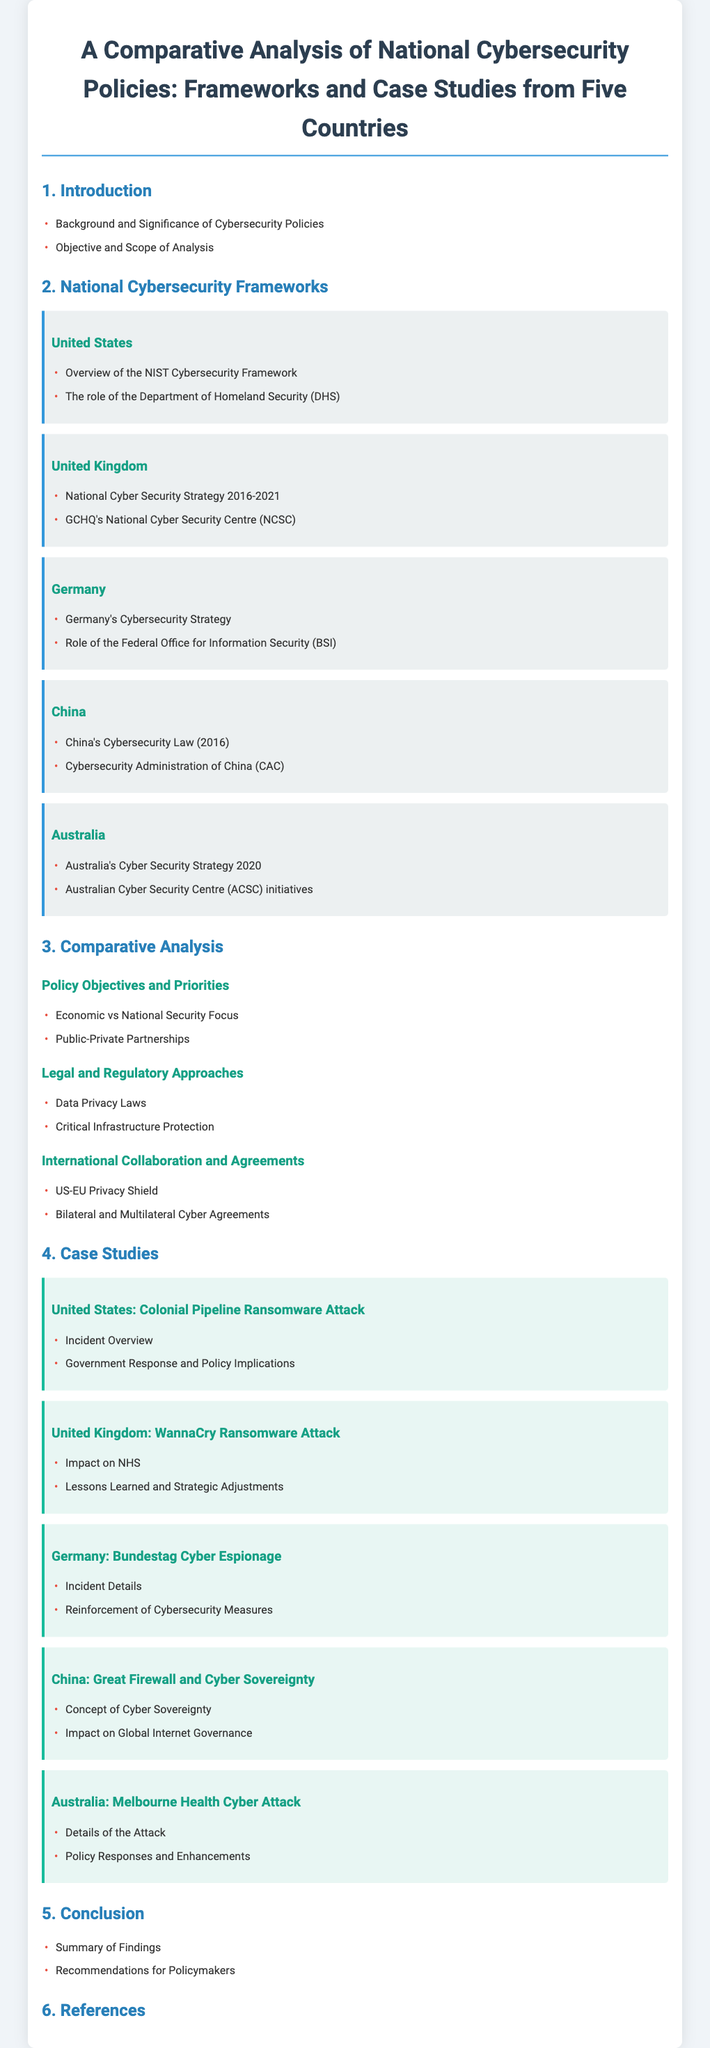What is the title of the document? The title is found at the top of the document, which summarizes the focus on national cybersecurity policies across different countries.
Answer: A Comparative Analysis of National Cybersecurity Policies: Frameworks and Case Studies from Five Countries Which country has the National Cyber Security Strategy 2016-2021? This information can be found in the overview of national cybersecurity frameworks under the United Kingdom section.
Answer: United Kingdom What year was China's Cybersecurity Law enacted? The year is stated in the section discussing China's cybersecurity framework and laws.
Answer: 2016 What is the primary focus of the United States' NIST Cybersecurity Framework? This information is included under the overview of the framework provided for the United States.
Answer: Cybersecurity Which attack impacted the UK's National Health Service? This is a specific case study covered in the document discussing significant cybersecurity incidents.
Answer: WannaCry Ransomware Attack What does Germany's Federal Office for Information Security (BSI) primarily handle? This detail is mentioned in the description of Germany's cybersecurity framework.
Answer: Cybersecurity What type of partnerships are emphasized in the comparative analysis of policy objectives? This part of the document addresses collaborative efforts in the context of national cybersecurity policies.
Answer: Public-Private Partnerships How many countries' cybersecurity frameworks are analyzed? The overall structure of the document indicates the number of case studies included.
Answer: Five What significant theme is explored in the legal and regulatory approaches section? This aspect is derived from the comparative analysis of how laws affect cybersecurity practices.
Answer: Data Privacy Laws 